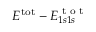Convert formula to latex. <formula><loc_0><loc_0><loc_500><loc_500>E ^ { t o t } - E _ { 1 s 1 s } ^ { t o t }</formula> 